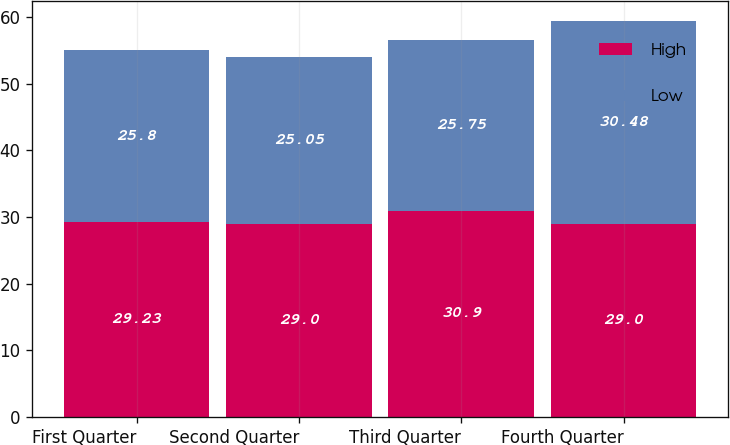<chart> <loc_0><loc_0><loc_500><loc_500><stacked_bar_chart><ecel><fcel>First Quarter<fcel>Second Quarter<fcel>Third Quarter<fcel>Fourth Quarter<nl><fcel>High<fcel>29.23<fcel>29<fcel>30.9<fcel>29<nl><fcel>Low<fcel>25.8<fcel>25.05<fcel>25.75<fcel>30.48<nl></chart> 